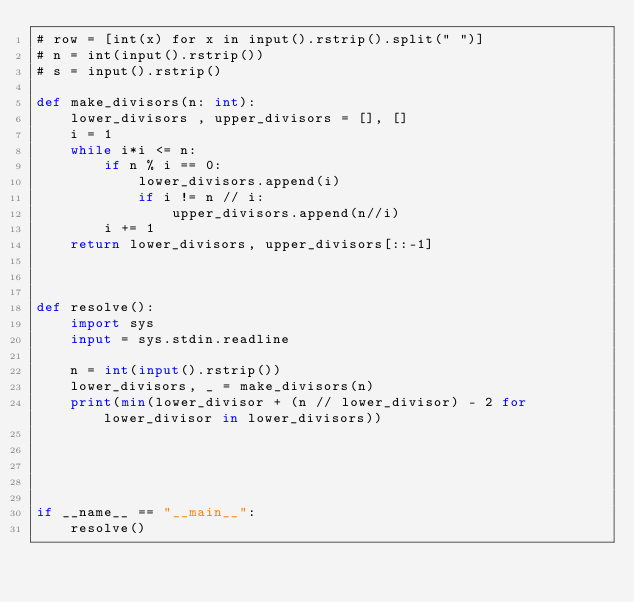<code> <loc_0><loc_0><loc_500><loc_500><_Python_># row = [int(x) for x in input().rstrip().split(" ")]
# n = int(input().rstrip())
# s = input().rstrip()

def make_divisors(n: int):
    lower_divisors , upper_divisors = [], []
    i = 1
    while i*i <= n:
        if n % i == 0:
            lower_divisors.append(i)
            if i != n // i:
                upper_divisors.append(n//i)
        i += 1
    return lower_divisors, upper_divisors[::-1]



def resolve():
    import sys
    input = sys.stdin.readline

    n = int(input().rstrip())
    lower_divisors, _ = make_divisors(n)
    print(min(lower_divisor + (n // lower_divisor) - 2 for lower_divisor in lower_divisors))





if __name__ == "__main__":
    resolve()
</code> 